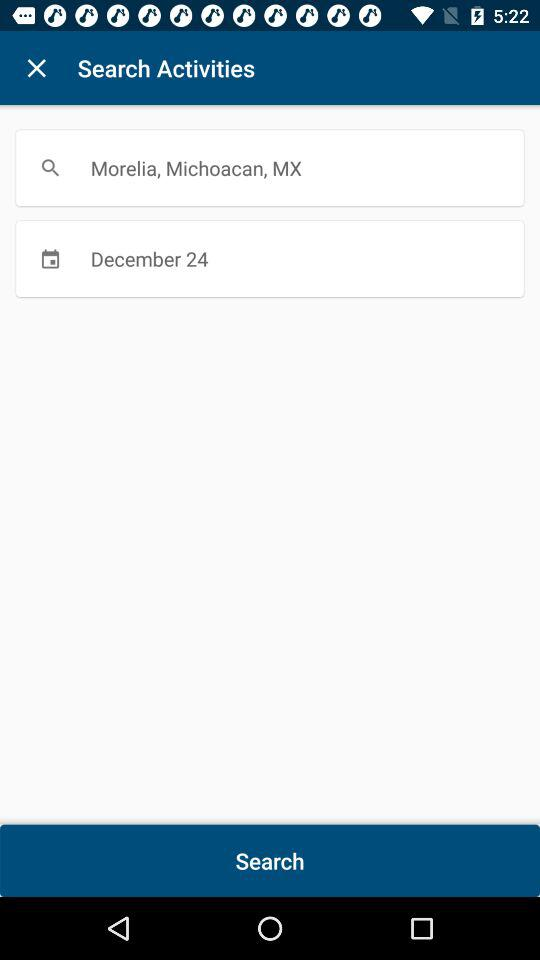What is the selected date? The selected date is December 24. 